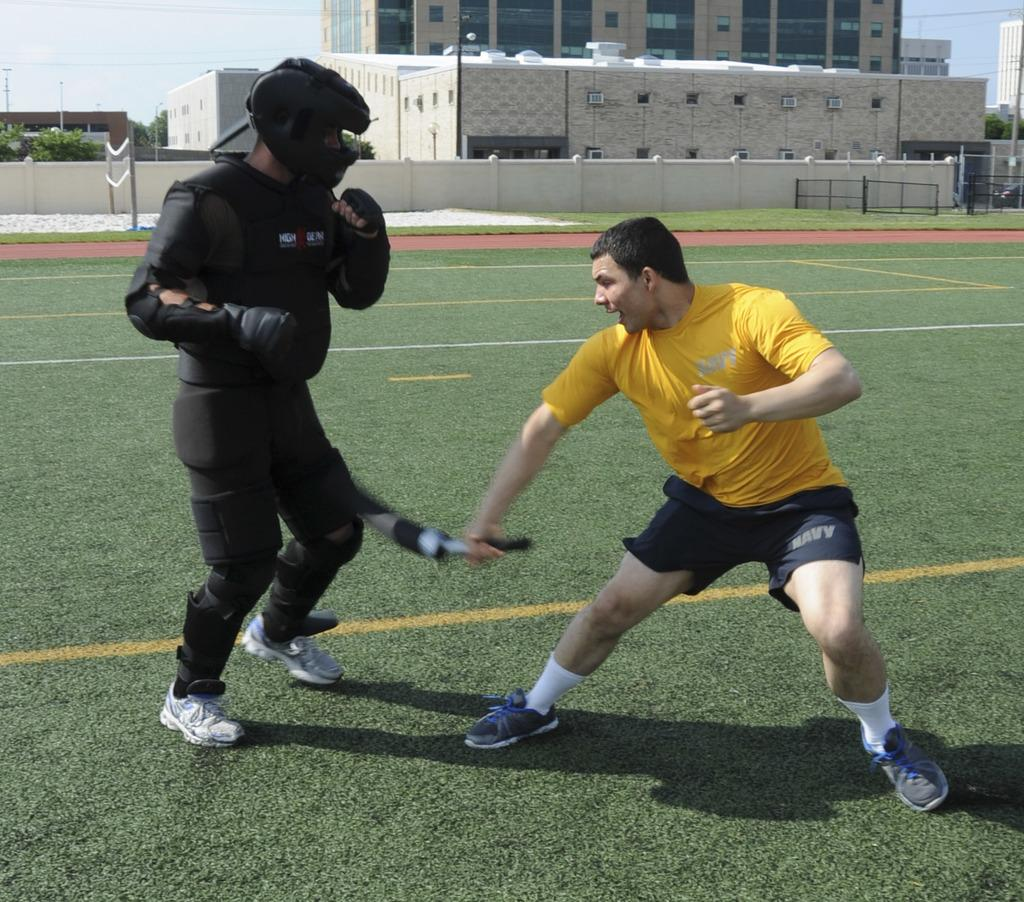<image>
Provide a brief description of the given image. A man in a pair of Navy shorts spars with a person wearing black padding. 